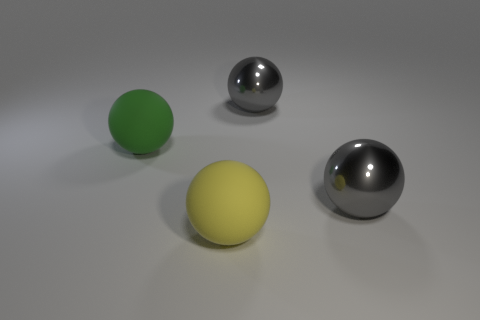What material is the thing that is to the left of the rubber ball in front of the large matte sphere on the left side of the large yellow object?
Offer a terse response. Rubber. Does the big yellow sphere have the same material as the gray sphere that is in front of the large green matte object?
Offer a terse response. No. Is the number of yellow spheres that are behind the large green rubber thing less than the number of big things to the left of the large yellow matte sphere?
Make the answer very short. Yes. What number of big gray objects are made of the same material as the large yellow thing?
Give a very brief answer. 0. There is a ball that is to the left of the rubber object to the right of the green sphere; is there a large object right of it?
Your response must be concise. Yes. What number of spheres are green rubber objects or yellow matte objects?
Your answer should be compact. 2. Do the big green thing and the rubber thing that is on the right side of the big green object have the same shape?
Make the answer very short. Yes. Is the number of spheres that are to the right of the large yellow thing less than the number of rubber spheres?
Provide a short and direct response. No. There is a large green rubber object; are there any rubber objects to the right of it?
Make the answer very short. Yes. Are there any other big metallic things of the same shape as the big green thing?
Provide a short and direct response. Yes. 